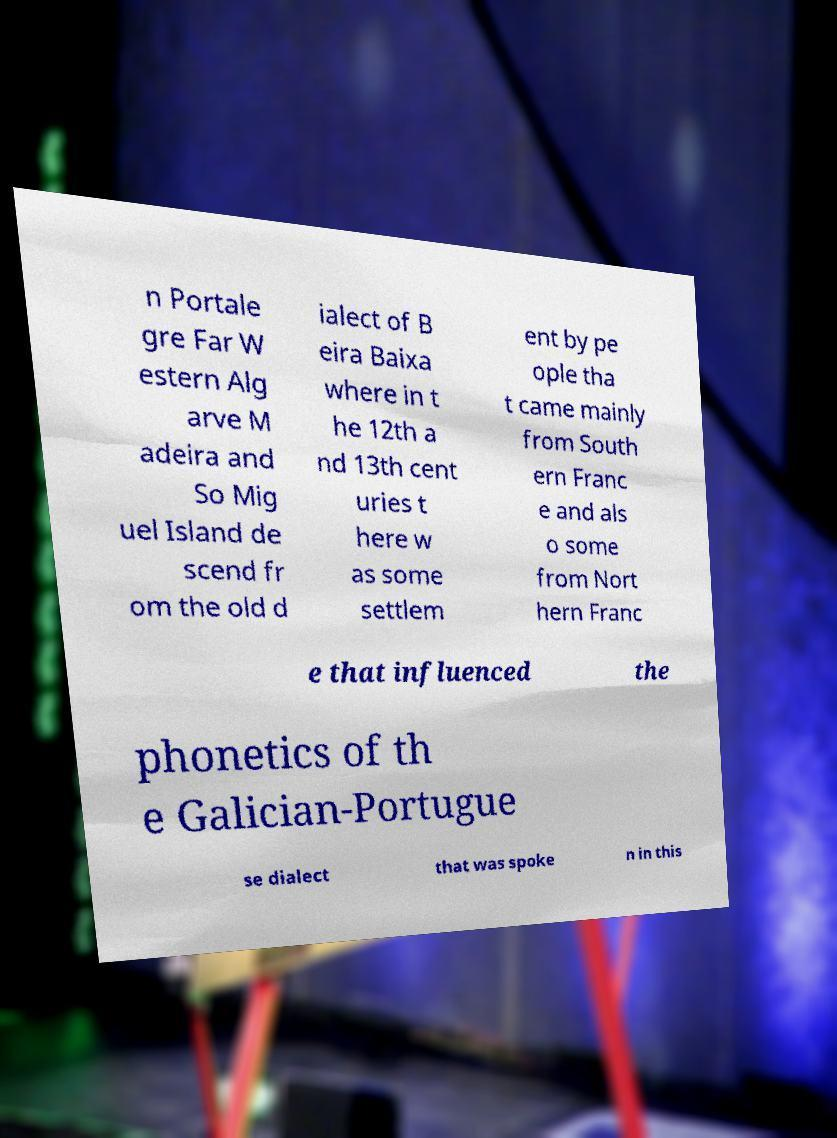For documentation purposes, I need the text within this image transcribed. Could you provide that? n Portale gre Far W estern Alg arve M adeira and So Mig uel Island de scend fr om the old d ialect of B eira Baixa where in t he 12th a nd 13th cent uries t here w as some settlem ent by pe ople tha t came mainly from South ern Franc e and als o some from Nort hern Franc e that influenced the phonetics of th e Galician-Portugue se dialect that was spoke n in this 